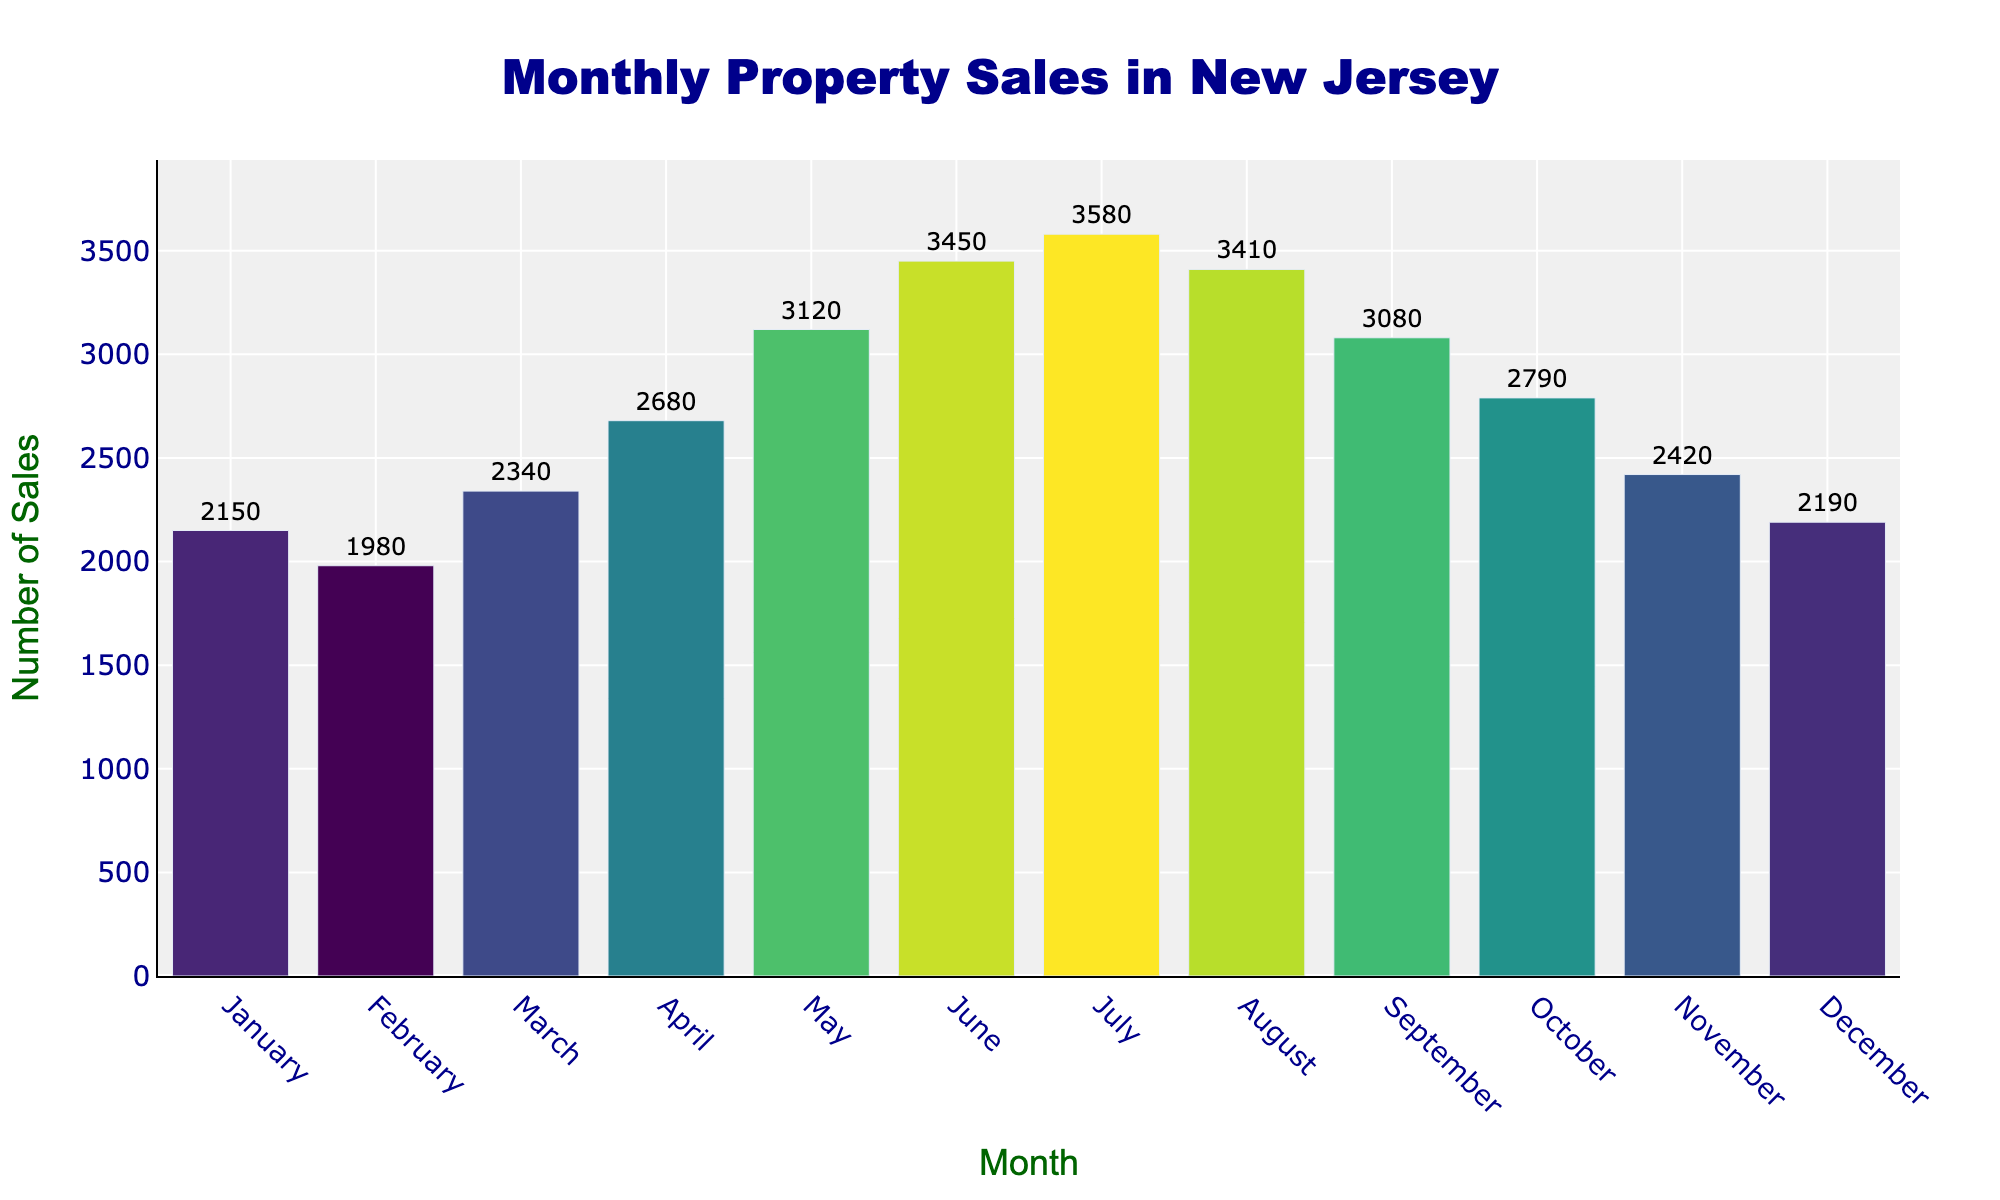What's the title of the figure? The title of the figure is prominently displayed at the top center of the histogram.
Answer: Monthly Property Sales in New Jersey What is the total number of property sales in June? To find the number of property sales in June, look for the bar labeled "June" and read the value it reaches on the y-axis.
Answer: 3450 Which month had the highest number of property sales? Identify the tallest bar in the histogram and check the label on the x-axis below it.
Answer: July What is the difference in property sales between May and June? Find the values for property sales in May and June. Subtract May's sales from June's: 3450 - 3120.
Answer: 330 What is the average number of property sales per month? Sum all the sales numbers for each month and divide by 12: (2150 + 1980 + 2340 + 2680 + 3120 + 3450 + 3580 + 3410 + 3080 + 2790 + 2420 + 2190) / 12.
Answer: 2828.33 Which months had more than 3000 property sales? Identify all bars that extend above the 3000 mark on the y-axis and check the corresponding x-axis labels.
Answer: May, June, July, August, September How do property sales in December compare with those in January? Compare the heights of the bars for December and January by reading their values on the y-axis. December: 2190, January: 2150.
Answer: December had slightly higher sales What seasonal trend can be observed in the property sales data? Observe the pattern of the monthly sales bars, noting increases and decreases. Sales rise from January to July and then start to decline from August to December.
Answer: Sales peak in the summer months and decline towards the end of the year What is the sum of the property sales in the first quarter (January to March)? Sum the values for January, February, and March: 2150 + 1980 + 2340.
Answer: 6470 Which month had the lowest number of property sales, and what was the value? Identify the shortest bar in the histogram and check the label on the x-axis below it.
Answer: February, 1980 